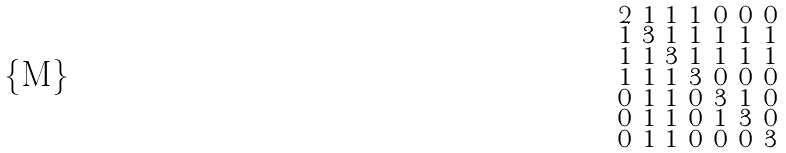Convert formula to latex. <formula><loc_0><loc_0><loc_500><loc_500>\begin{smallmatrix} 2 & 1 & 1 & 1 & 0 & 0 & 0 \\ 1 & 3 & 1 & 1 & 1 & 1 & 1 \\ 1 & 1 & 3 & 1 & 1 & 1 & 1 \\ 1 & 1 & 1 & 3 & 0 & 0 & 0 \\ 0 & 1 & 1 & 0 & 3 & 1 & 0 \\ 0 & 1 & 1 & 0 & 1 & 3 & 0 \\ 0 & 1 & 1 & 0 & 0 & 0 & 3 \end{smallmatrix}</formula> 